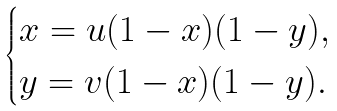Convert formula to latex. <formula><loc_0><loc_0><loc_500><loc_500>\begin{cases} x = u ( 1 - x ) ( 1 - y ) , \\ y = v ( 1 - x ) ( 1 - y ) . \end{cases}</formula> 